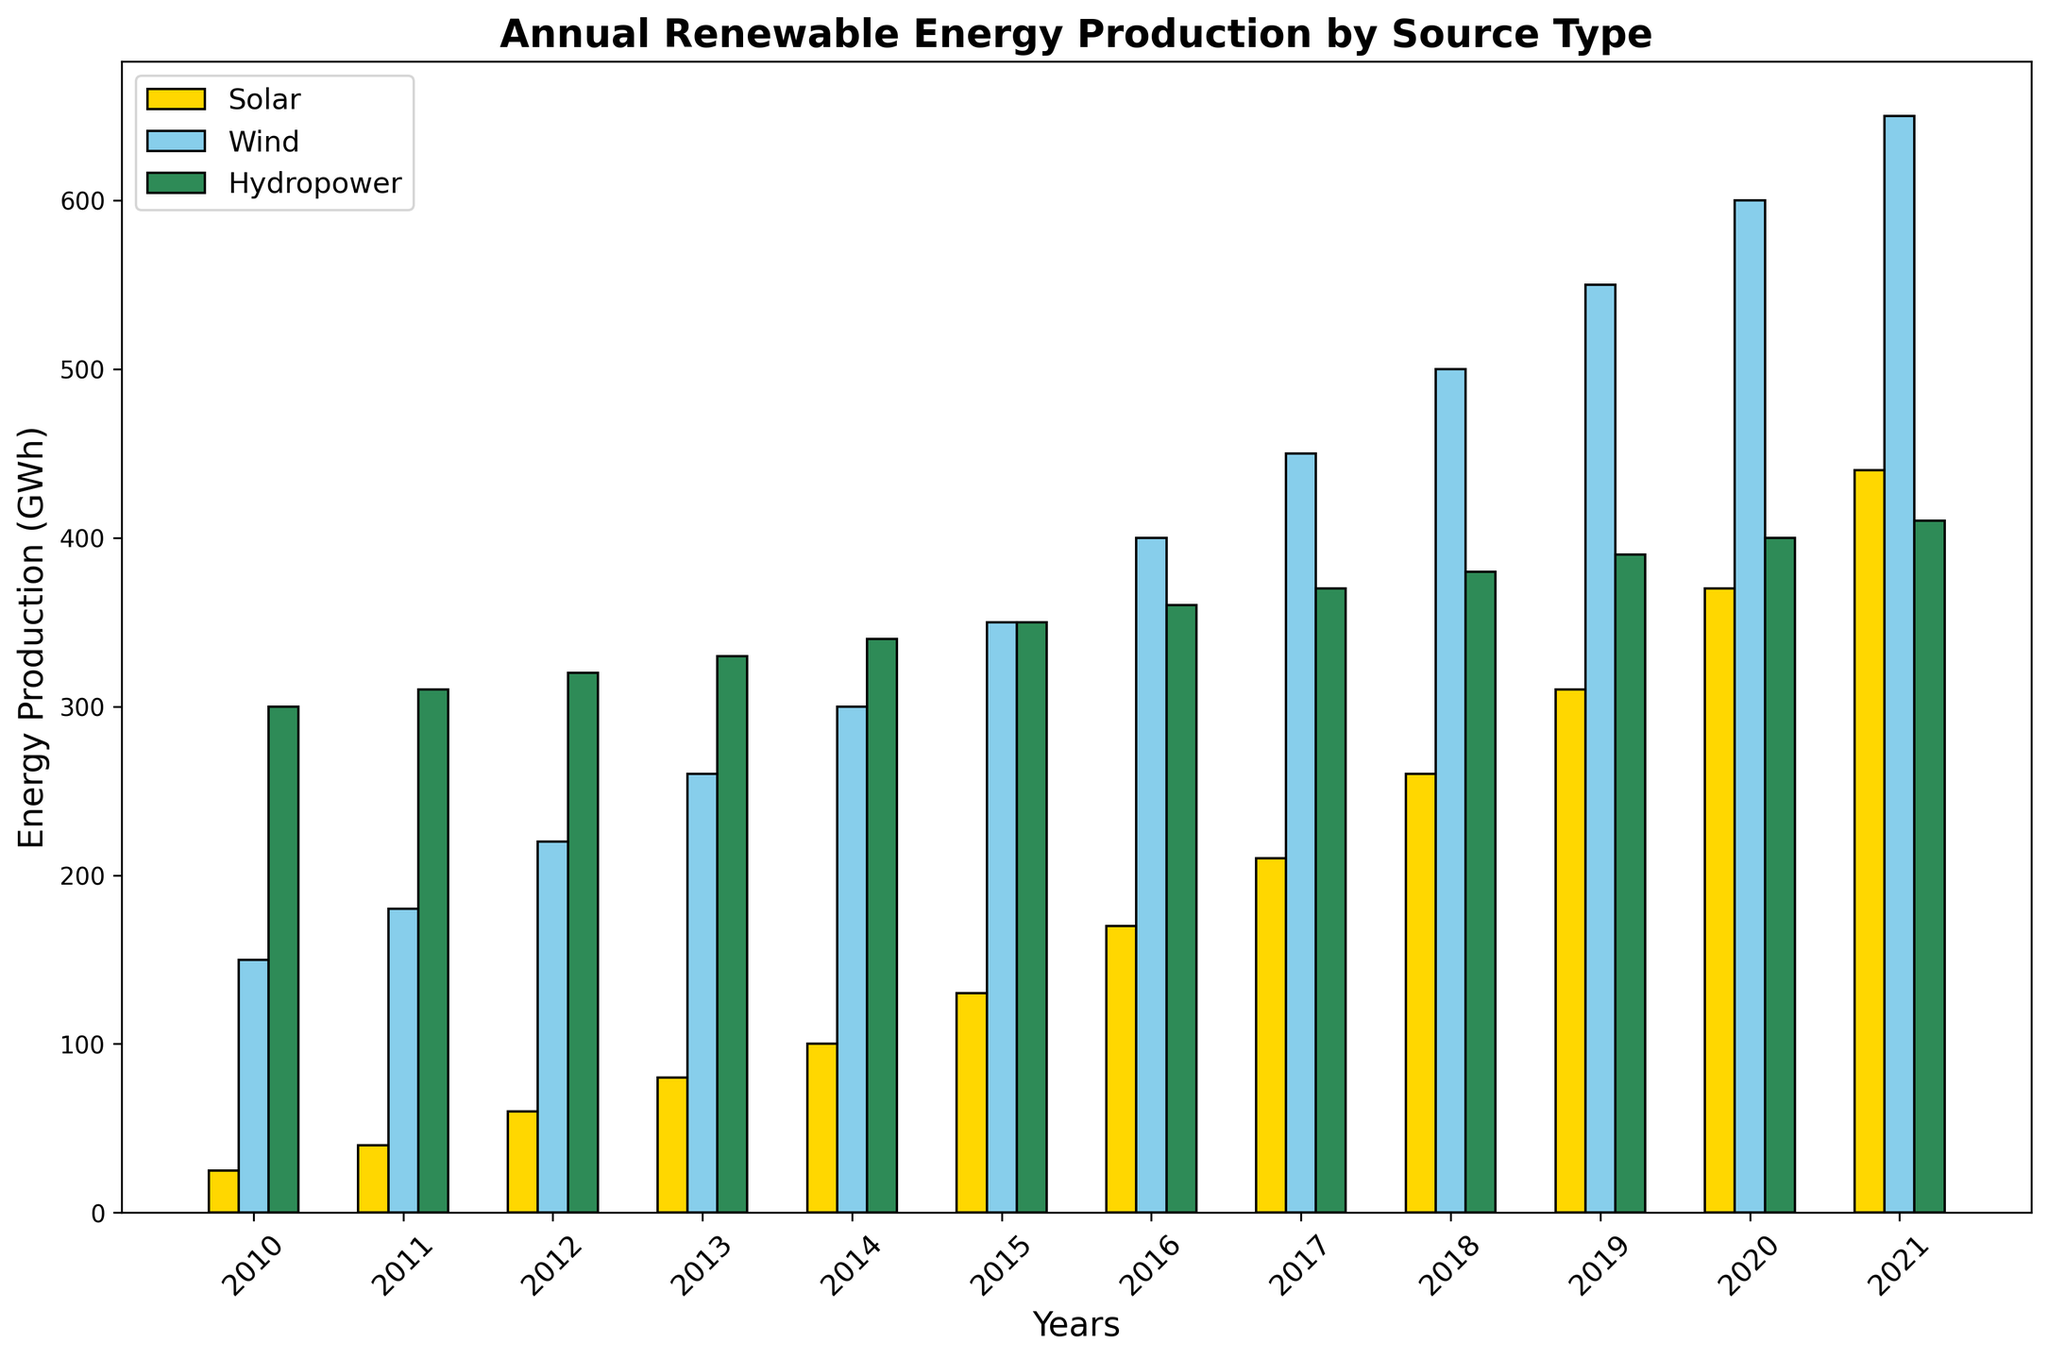What year had the highest solar energy production? Identify the bar with the highest value for the solar category (gold color). The highest bar for solar is in the year 2021.
Answer: 2021 How much more energy did wind produce than hydropower in 2020? Find the bars for wind and hydropower in 2020, then subtract the value for hydropower from the value for wind: 600 (wind) - 400 (hydropower) = 200.
Answer: 200 GWh Which energy source showed the most significant increase in production between 2010 and 2021? Compare the values of each energy source in 2010 and 2021. Solar increased from 25 to 440 (415 GWh), wind from 150 to 650 (500 GWh), and hydropower from 300 to 410 (110 GWh). Wind had the most significant increase.
Answer: Wind What is the average annual production of hydropower from 2010 to 2021? Sum the hydropower values from 2010 to 2021 and divide by the number of years: (300 + 310 + 320 + 330 + 340 + 350 + 360 + 370 + 380 + 390 + 400 + 410)/12 = 358.33.
Answer: 358.33 GWh In which year did solar energy production first exceed 200 GWh? Identify the first year where the solar energy production bar (gold color) exceeds the 200-mark on the y-axis. This occurs in 2017.
Answer: 2017 How did wind energy production change from 2015 to 2020? Look at the wind energy production bars for 2015 and 2020. Subtract the production in 2015 from the production in 2020: 600 - 350 = 250.
Answer: Increased by 250 GWh Which year had the lowest total renewable energy production (sum of all three sources)? Calculate the total production for each year by adding solar, wind, and hydropower values and compare them. For instance:
2010: 25 + 150 + 300 = 475
2011: 40 + 180 + 310 = 530
...
2021: 440 + 650 + 410 = 1500
The lowest total (475 GWh) is in 2010.
Answer: 2010 Between 2018 and 2021, which energy source showed the least growth? Calculate the difference in production for each source from 2018 to 2021:
Solar: 440 - 260 = 180
Wind: 650 - 500 = 150
Hydropower: 410 - 380 = 30
Hydropower had the smallest increase.
Answer: Hydropower What is the difference in annual production between the highest and lowest values for hydropower from 2010 to 2021? Determine the highest and lowest values for hydropower within the given range. The highest value for hydropower is 410 in 2021, and the lowest is 300 in 2010. The difference is 410 - 300 = 110.
Answer: 110 GWh 백 